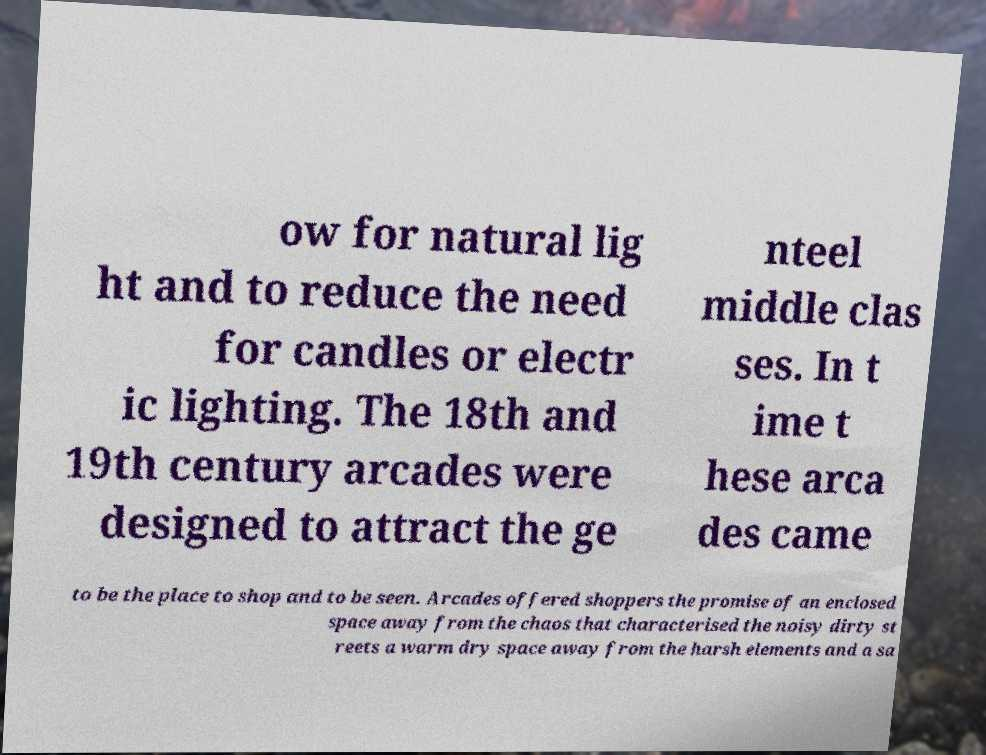Please identify and transcribe the text found in this image. ow for natural lig ht and to reduce the need for candles or electr ic lighting. The 18th and 19th century arcades were designed to attract the ge nteel middle clas ses. In t ime t hese arca des came to be the place to shop and to be seen. Arcades offered shoppers the promise of an enclosed space away from the chaos that characterised the noisy dirty st reets a warm dry space away from the harsh elements and a sa 